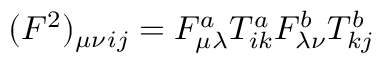<formula> <loc_0><loc_0><loc_500><loc_500>( F ^ { 2 } ) _ { \mu \nu _ { i j } = F _ { \mu \lambda } ^ { a } T _ { i k } ^ { a } F _ { \lambda \nu } ^ { b } T _ { k j } ^ { b }</formula> 